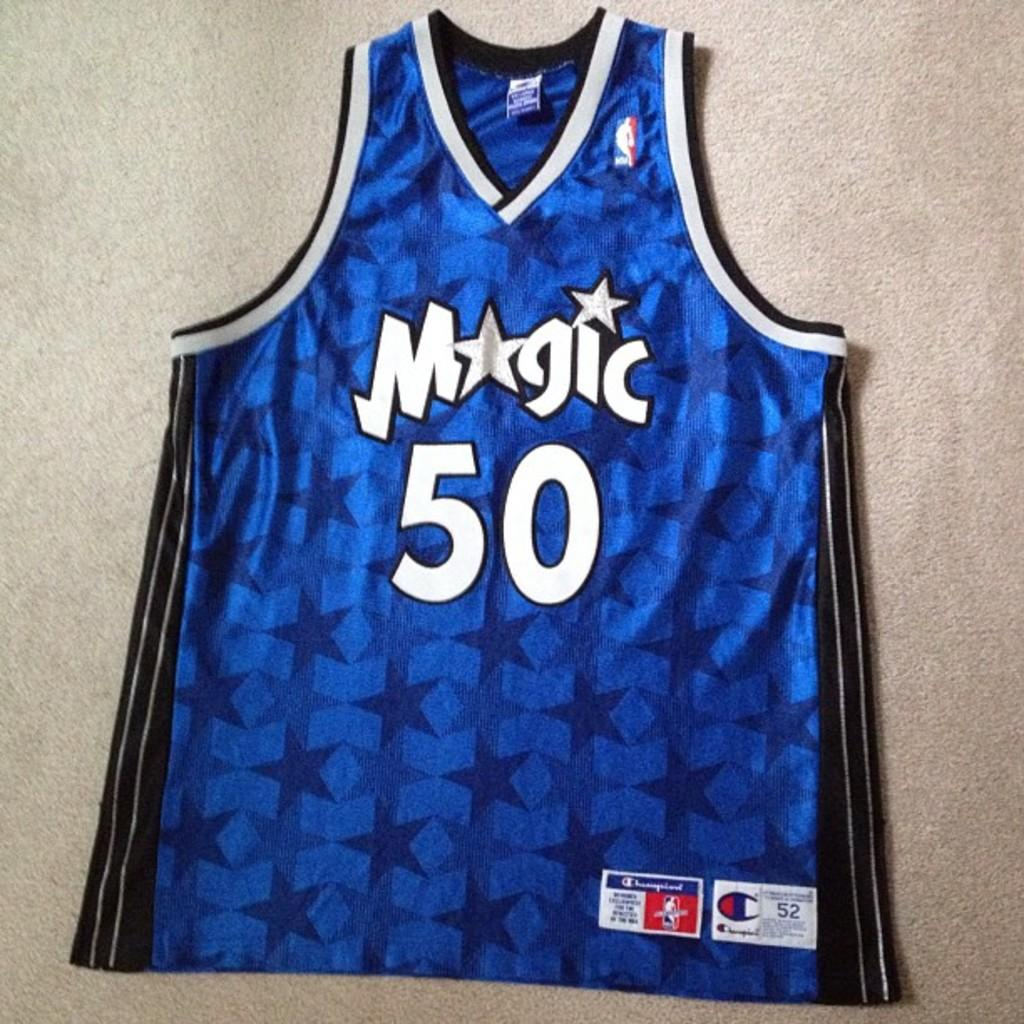What color is the shirt in the picture? The shirt in the picture is blue. Is there any text or design on the shirt? Yes, there is something written on the shirt. What is the shirt placed on in the picture? The shirt is placed on a grey surface. Are there any spiders crawling on the metal surface in the image? There is no metal surface or spiders present in the image. 